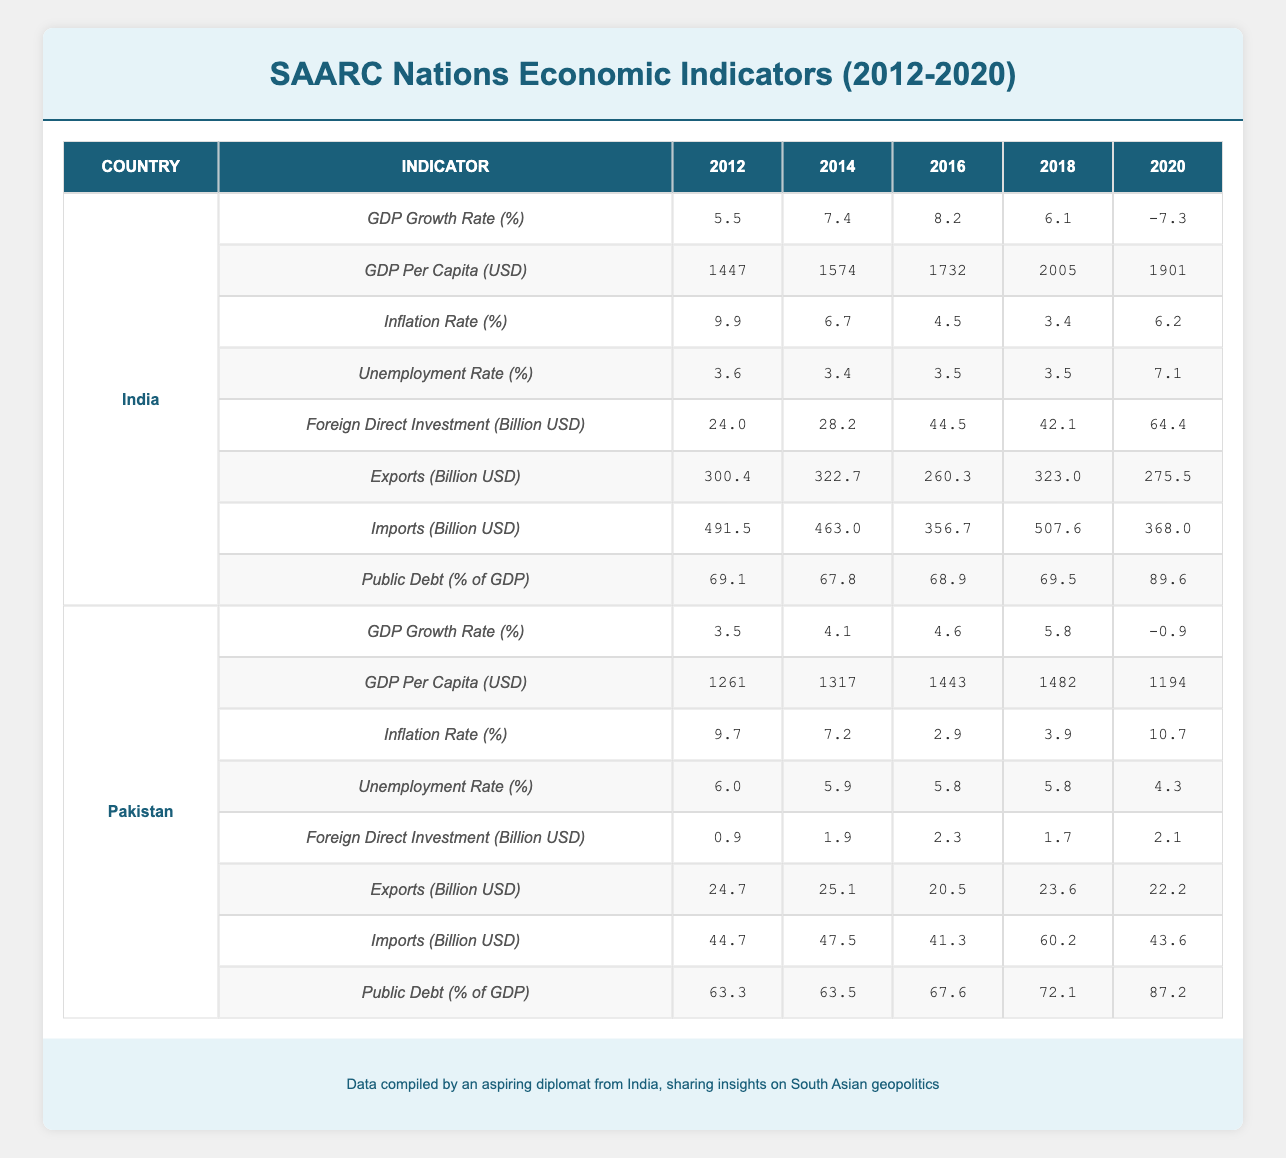What was India's GDP growth rate in 2016? From the table, we look at the row corresponding to India under the GDP Growth Rate (%) indicator for the year 2016. The value listed there is 8.2.
Answer: 8.2 Which country had the highest GDP per capita in 2020? Looking through the GDP Per Capita (USD) values for the year 2020, we find that the Maldives has the highest value at 7456 USD.
Answer: Maldives What was the average inflation rate for Bangladesh over the years? The inflation rates for Bangladesh across the available years are 6.2, 7.0, 5.5, 5.5, and 5.7. Adding these values gives a total of 30.9. Dividing this by 5 (the number of years) results in an average inflation rate of 6.18.
Answer: 6.18 Did Bhutan's public debt as a percentage of GDP increase from 2012 to 2020? We need to compare the public debt percentage from the years 2012 and 2020. In 2012, it was 85.6%, and in 2020 it rose to 120.7%. Since 120.7 is greater than 85.6, the answer is yes.
Answer: Yes What was the difference between Sri Lanka's GDP growth rate in 2012 and in 2020? The GDP growth rate for Sri Lanka in 2012 was 9.1 and in 2020 it was -3.6. To find the difference, subtract -3.6 from 9.1: 9.1 - (-3.6) = 12.7. Hence, the difference is 12.7.
Answer: 12.7 What was the trend in Nepal's GDP growth rate from 2012 to 2020? Examining the GDP growth rates for Nepal: 4.8 (2012), 6.0 (2014), 0.6 (2016), 6.7 (2018), -2.1 (2020), we see fluctuations with an overall decline towards 2020, ending with a negative growth.
Answer: Declining trend Did Pakistan's foreign direct investment in 2020 exceed its total foreign direct investment in 2012? The foreign direct investment (FDI) for Pakistan in 2020 was 2.1 billion USD, while in 2012 it was 0.9 billion USD. Since 2.1 is greater than 0.9, the answer is yes.
Answer: Yes What was the combined value of imports for Afghanistan and Bhutan in 2018? For Afghanistan, the imports in 2018 were 7.4 billion USD and for Bhutan, it was 1.1 billion USD. Adding these together gives: 7.4 + 1.1 = 8.5 billion USD.
Answer: 8.5 billion USD What country experienced the highest inflation rate in 2020? Checking the inflation rates for 2020, the highest rate is 10.7% for Pakistan. Thus, Pakistan experienced the highest inflation rate among the listed countries.
Answer: Pakistan 